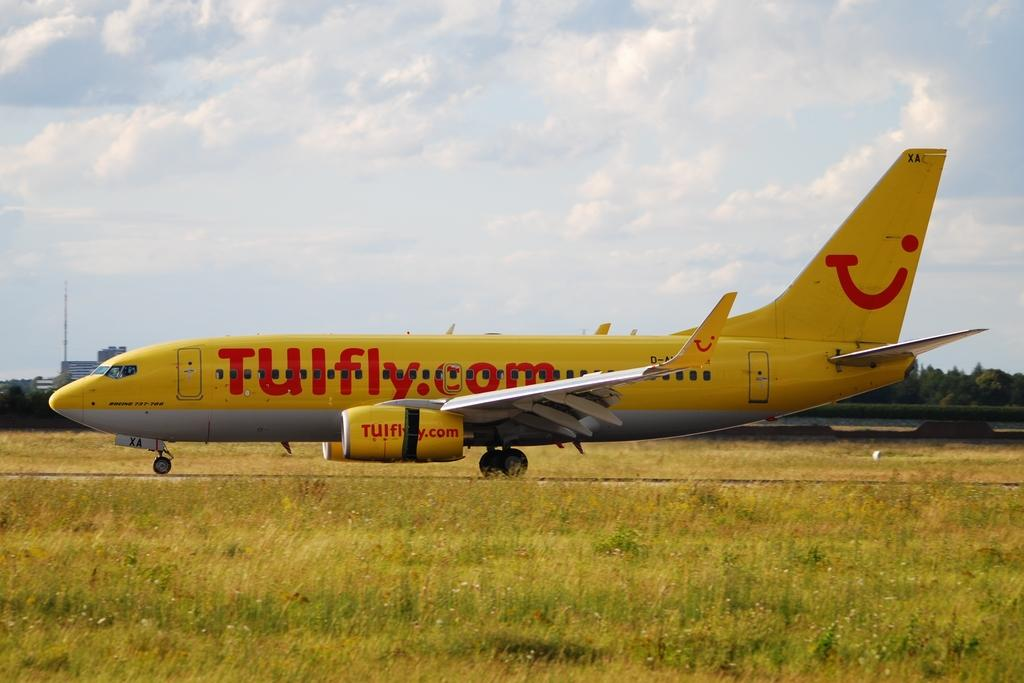What color is the aeroplane in the image? The aeroplane in the image is yellow. What is the terrain like in the image? The land is covered with grass. What is visible in the sky in the image? The sky is covered with clouds. What type of vegetation can be seen in the background of the image? Trees are present in the background of the image. What type of locket is hanging from the trees in the image? There is no locket present in the image; it features an aeroplane, grass-covered land, cloudy sky, and trees in the background. 